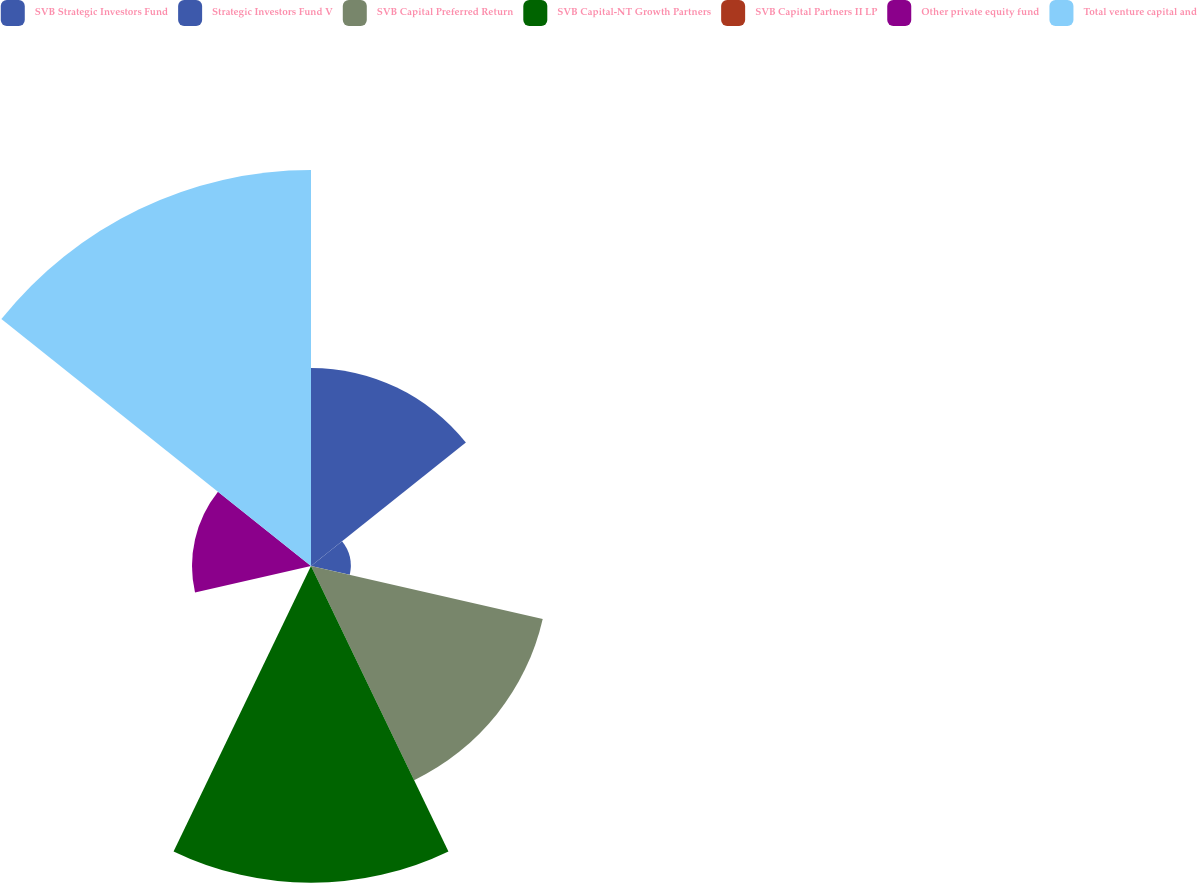<chart> <loc_0><loc_0><loc_500><loc_500><pie_chart><fcel>SVB Strategic Investors Fund<fcel>Strategic Investors Fund V<fcel>SVB Capital Preferred Return<fcel>SVB Capital-NT Growth Partners<fcel>SVB Capital Partners II LP<fcel>Other private equity fund<fcel>Total venture capital and<nl><fcel>15.15%<fcel>3.04%<fcel>18.18%<fcel>24.23%<fcel>0.01%<fcel>9.1%<fcel>30.29%<nl></chart> 